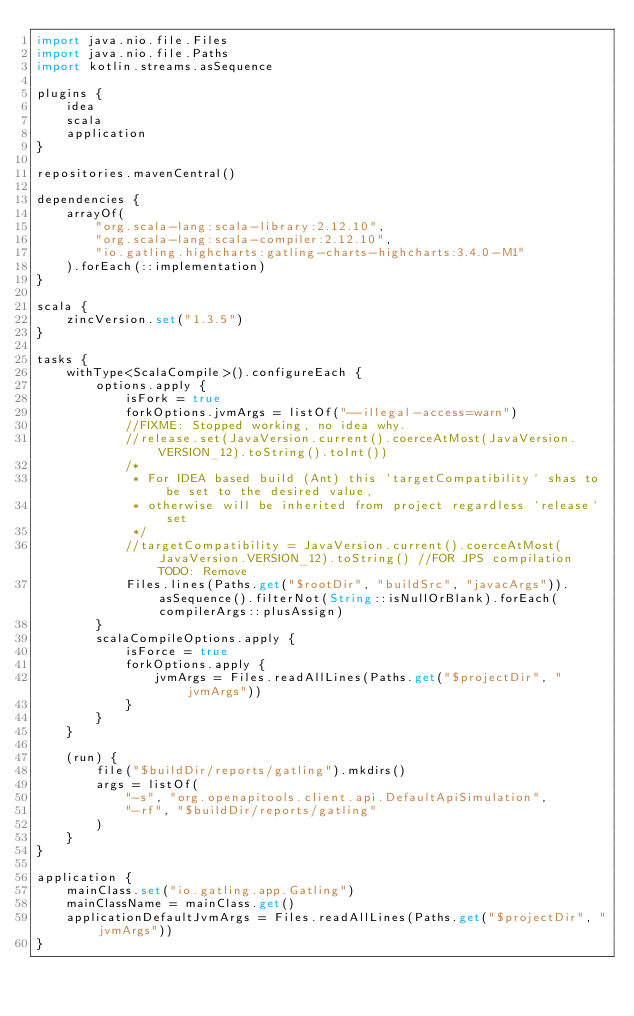Convert code to text. <code><loc_0><loc_0><loc_500><loc_500><_Kotlin_>import java.nio.file.Files
import java.nio.file.Paths
import kotlin.streams.asSequence

plugins {
    idea
    scala
    application
}

repositories.mavenCentral()

dependencies {
    arrayOf(
        "org.scala-lang:scala-library:2.12.10",
        "org.scala-lang:scala-compiler:2.12.10",
        "io.gatling.highcharts:gatling-charts-highcharts:3.4.0-M1"
    ).forEach(::implementation)
}

scala {
    zincVersion.set("1.3.5")
}

tasks {
    withType<ScalaCompile>().configureEach {
        options.apply {
            isFork = true
            forkOptions.jvmArgs = listOf("--illegal-access=warn")
            //FIXME: Stopped working, no idea why.
            //release.set(JavaVersion.current().coerceAtMost(JavaVersion.VERSION_12).toString().toInt())
            /*
             * For IDEA based build (Ant) this `targetCompatibility` shas to be set to the desired value,
             * otherwise will be inherited from project regardless `release` set
             */
            //targetCompatibility = JavaVersion.current().coerceAtMost(JavaVersion.VERSION_12).toString() //FOR JPS compilation  TODO: Remove
            Files.lines(Paths.get("$rootDir", "buildSrc", "javacArgs")).asSequence().filterNot(String::isNullOrBlank).forEach(compilerArgs::plusAssign)
        }
        scalaCompileOptions.apply {
            isForce = true
            forkOptions.apply {
                jvmArgs = Files.readAllLines(Paths.get("$projectDir", "jvmArgs"))
            }
        }
    }

    (run) {
        file("$buildDir/reports/gatling").mkdirs()
        args = listOf(
            "-s", "org.openapitools.client.api.DefaultApiSimulation",
            "-rf", "$buildDir/reports/gatling"
        )
    }
}

application {
    mainClass.set("io.gatling.app.Gatling")
    mainClassName = mainClass.get()
    applicationDefaultJvmArgs = Files.readAllLines(Paths.get("$projectDir", "jvmArgs"))
}
</code> 